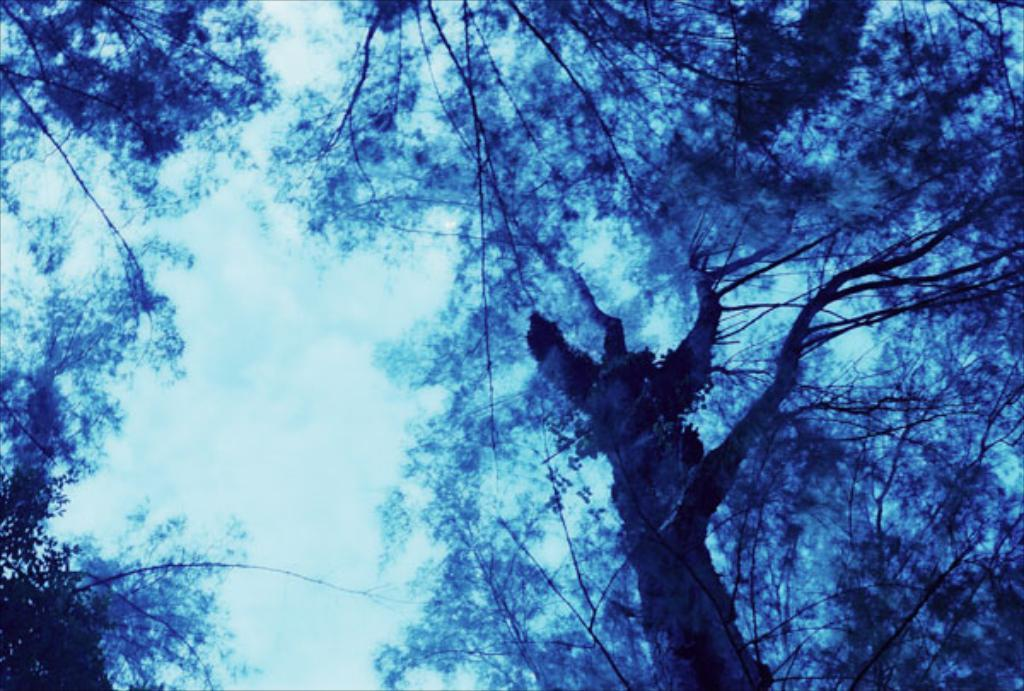What type of vegetation can be seen in the image? There are trees in the image. What part of the natural environment is visible in the image? The sky is visible in the background of the image. What word is being spoken by the trees in the image? There are no words spoken by the trees in the image, as trees do not have the ability to speak. 